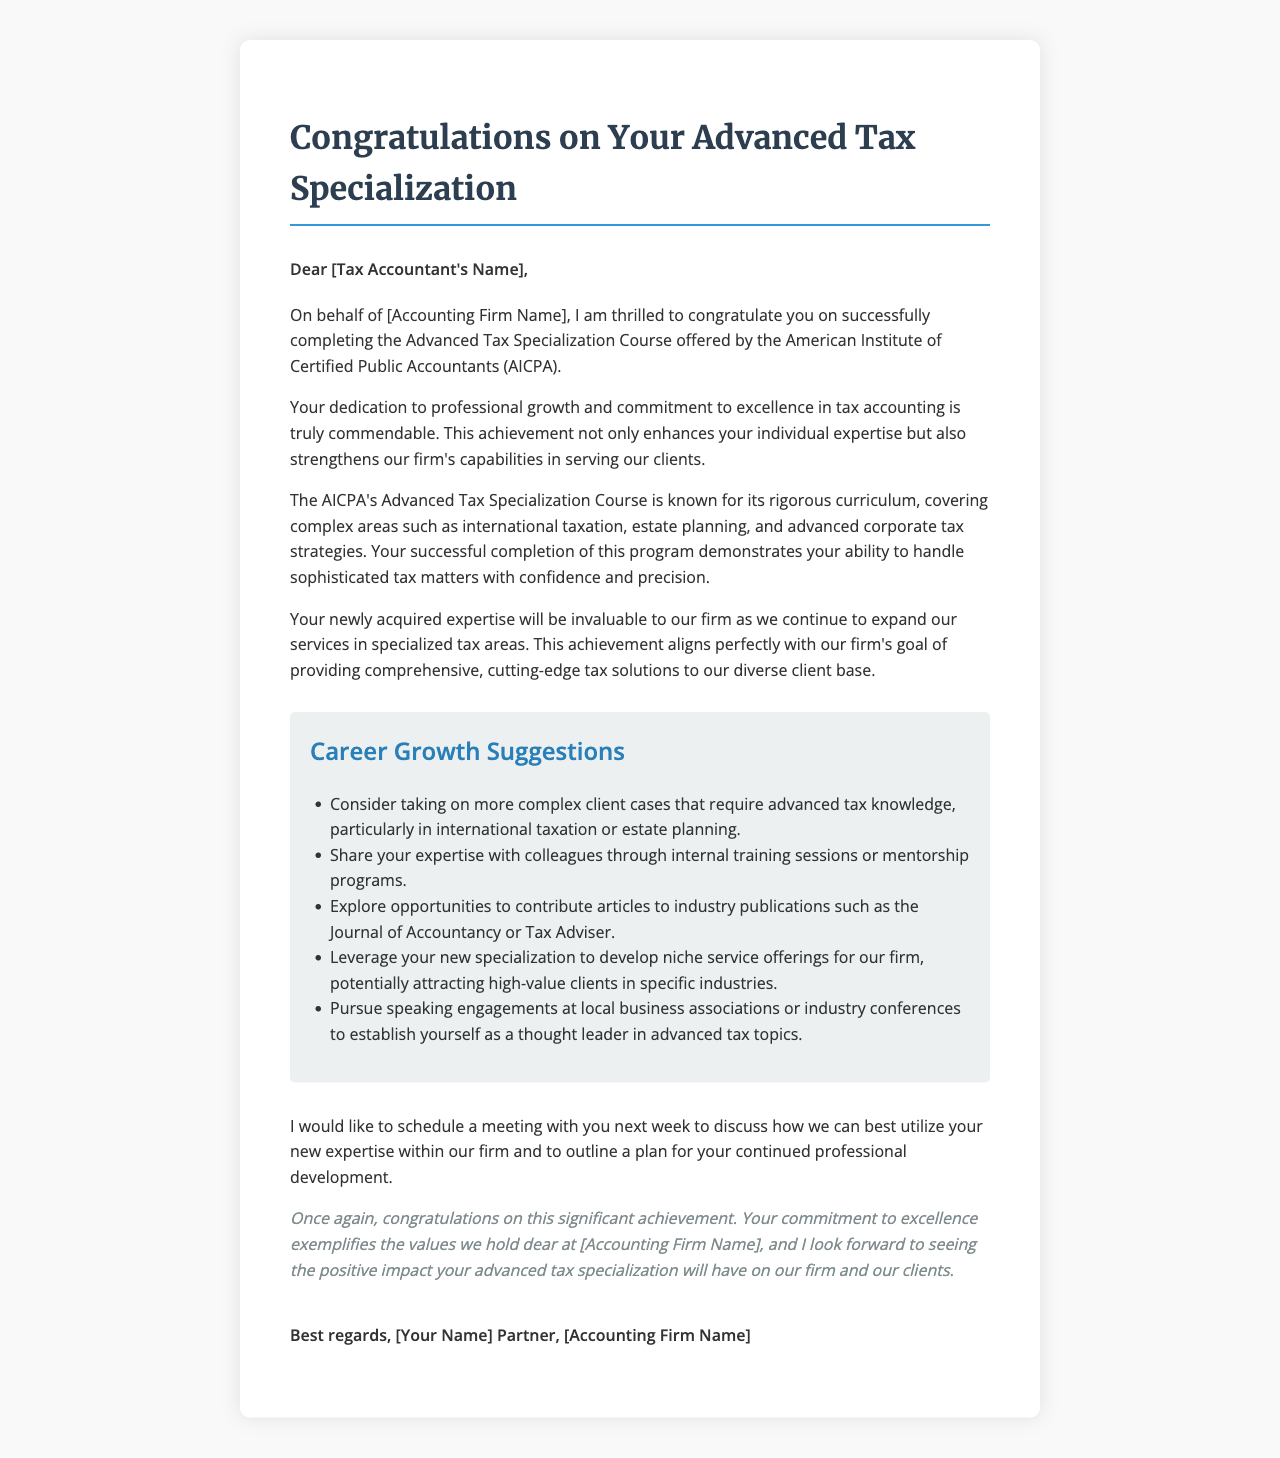What is the name of the tax accountant? The document specifies the name of the tax accountant who completed the course.
Answer: Sarah Johnson Who is the partner signing the letter? The letter is signed by a partner of the firm, which is indicated in the signature section.
Answer: Michael Chen What course did the tax accountant complete? The document mentions the name of the advanced course that the tax accountant successfully completed.
Answer: Advanced Tax Specialization Course What organization offered the course? The letter states which organization conducted the Advanced Tax Specialization Course.
Answer: American Institute of Certified Public Accountants (AICPA) What are the complex areas covered by the course? The letter outlines specific complex tax topics addressed in the course.
Answer: International taxation, estate planning, and advanced corporate tax strategies What is one suggestion for leveraging the new expertise? The letter provides multiple suggestions for the tax accountant to utilize their new skills.
Answer: Take on more complex client cases How many career growth suggestions are provided in the letter? The document lists a specific number of suggestions for career growth.
Answer: Five What is the firm’s name mentioned in the letter? The greeting and signature sections of the letter reveal the name of the accounting firm.
Answer: Deloitte 